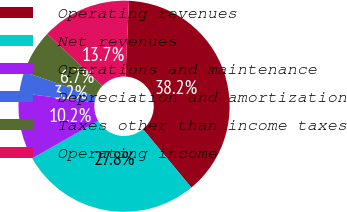<chart> <loc_0><loc_0><loc_500><loc_500><pie_chart><fcel>Operating revenues<fcel>Net revenues<fcel>Operations and maintenance<fcel>Depreciation and amortization<fcel>Taxes other than income taxes<fcel>Operating income<nl><fcel>38.24%<fcel>27.78%<fcel>10.24%<fcel>3.24%<fcel>6.74%<fcel>13.74%<nl></chart> 